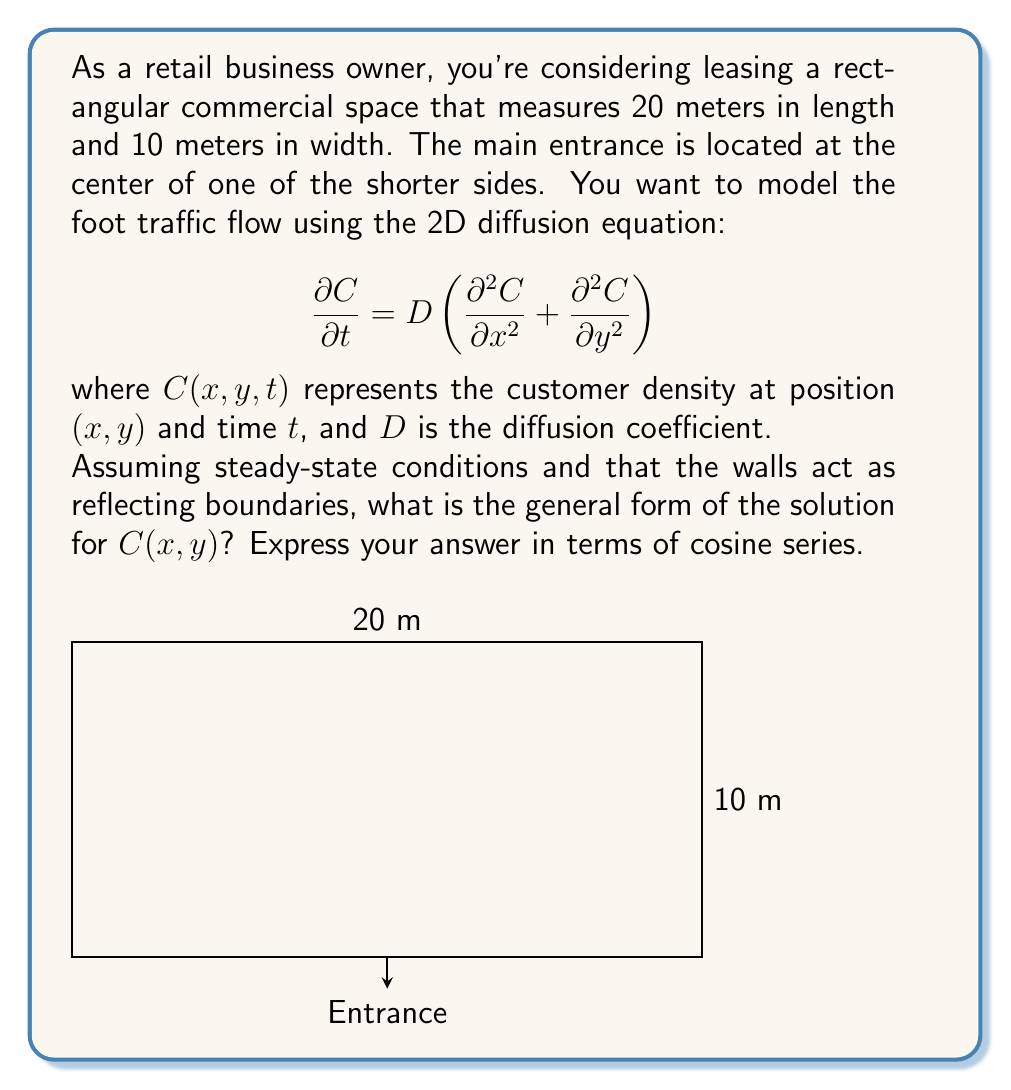What is the answer to this math problem? Let's approach this step-by-step:

1) In steady-state conditions, $\frac{\partial C}{\partial t} = 0$, so our equation reduces to:

   $$D \left(\frac{\partial^2 C}{\partial x^2} + \frac{\partial^2 C}{\partial y^2}\right) = 0$$

2) This is equivalent to Laplace's equation:

   $$\frac{\partial^2 C}{\partial x^2} + \frac{\partial^2 C}{\partial y^2} = 0$$

3) Given the rectangular shape and reflecting boundaries, we can use the method of separation of variables. Let $C(x,y) = X(x)Y(y)$.

4) Substituting this into Laplace's equation:

   $$Y\frac{d^2X}{dx^2} + X\frac{d^2Y}{dy^2} = 0$$

5) Dividing by $XY$:

   $$\frac{1}{X}\frac{d^2X}{dx^2} = -\frac{1}{Y}\frac{d^2Y}{dy^2} = -k^2$$

6) This gives us two ODEs:
   
   $$\frac{d^2X}{dx^2} + k^2X = 0$$
   $$\frac{d^2Y}{dy^2} - k^2Y = 0$$

7) The general solutions are:
   
   $$X(x) = A \cos(kx) + B \sin(kx)$$
   $$Y(y) = C e^{ky} + D e^{-ky}$$

8) Due to the reflecting boundaries at $x=0$ and $x=20$, we need $\frac{dX}{dx} = 0$ at these points. This condition is satisfied by:

   $$X(x) = A \cos(\frac{n\pi x}{20})$$

   where $n = 0, 1, 2, ...$

9) For $Y(y)$, we need a bounded solution as $y \to \infty$, so:

   $$Y(y) = D e^{-\frac{n\pi y}{20}}$$

10) The general solution is the sum of all possible solutions:

    $$C(x,y) = \sum_{n=0}^{\infty} A_n \cos(\frac{n\pi x}{20}) e^{-\frac{n\pi y}{20}}$$
Answer: $$C(x,y) = \sum_{n=0}^{\infty} A_n \cos(\frac{n\pi x}{20}) e^{-\frac{n\pi y}{20}}$$ 